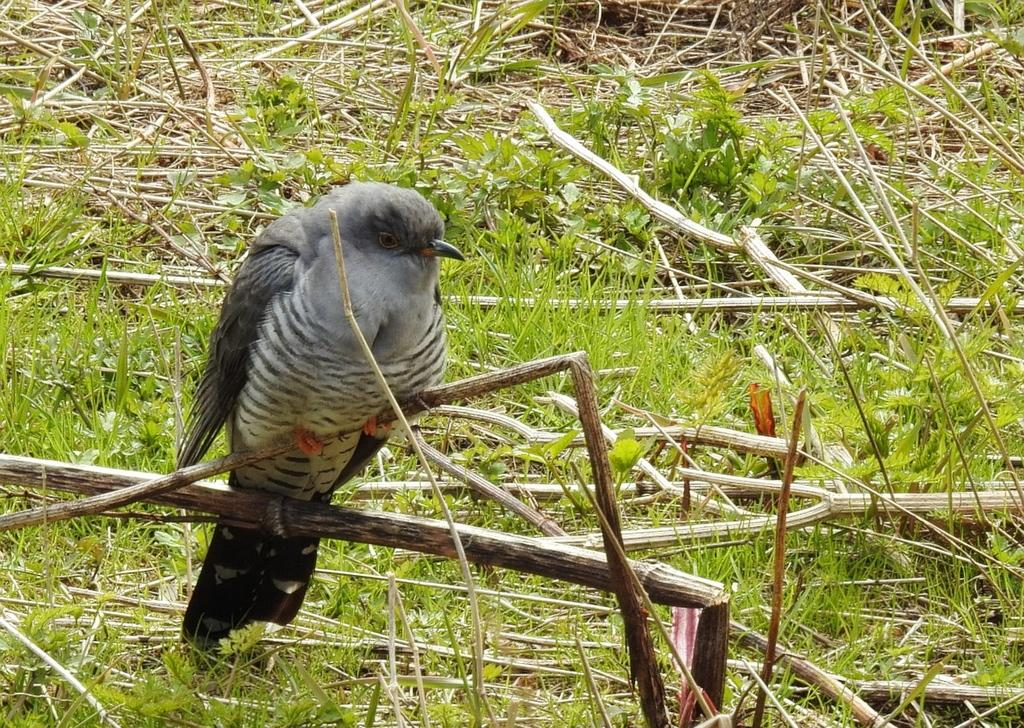What type of animal can be seen in the image? There is a bird in the image. Where is the bird located? The bird is on a branch. What type of vegetation is visible in the image? There are plants and grass visible in the image. What substance is the bird using to grip the branch in the image? The bird does not use a specific substance to grip the branch; birds have natural gripping abilities with their feet. 